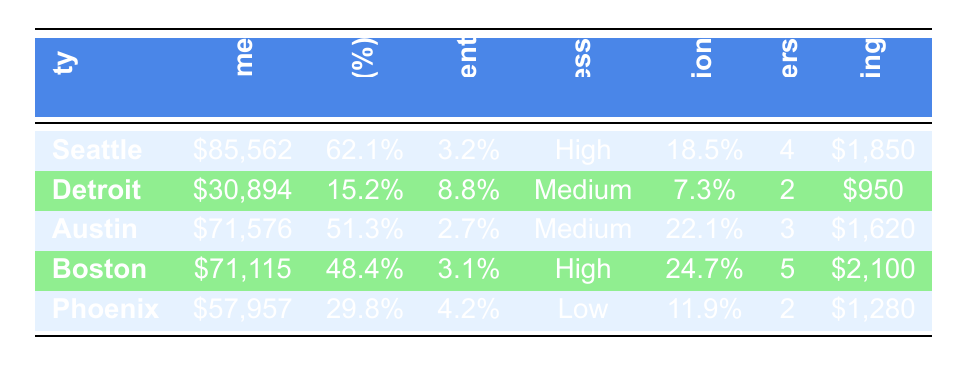What city has the highest median household income? Looking at the "Median Household Income" column, Seattle has the highest value at $85,562.
Answer: Seattle What is the science program participation rate for Boston? The "Science Program Participation Rate" for Boston is listed as 24.7%.
Answer: 24.7% Is the unemployment rate in Austin lower than that in Phoenix? Austin’s unemployment rate is 2.7%, while Phoenix’s is 4.2%, making Austin's rate lower.
Answer: Yes What is the average median household income of the cities listed? The median household incomes are $85,562 (Seattle), $30,894 (Detroit), $71,576 (Austin), $71,115 (Boston), and $57,957 (Phoenix). Summing these gives $317,104, and dividing by 5 cities gives an average of $63,420.8.
Answer: $63,420.8 Are there more local science centers in Seattle than in Detroit? Seattle has 4 local science centers while Detroit has only 2, so Seattle has more.
Answer: Yes What is the difference in science program participation rates between Austin and Detroit? Austin's rate is 22.1%, and Detroit's is 7.3%. To find the difference, subtract 7.3 from 22.1, resulting in 14.8%.
Answer: 14.8% Which city has the lowest education level percentage? By reviewing the "Education Level" column, we see that Detroit has the lowest percentage with 15.2%.
Answer: Detroit What city has both high public transportation access and the highest number of local science centers? Seattle has high public transportation access and has 4 local science centers, which is the highest number listed.
Answer: Seattle What is the STEM school funding per student for Boston and how does it compare to the funding in Detroit? Boston's STEM school funding is $2,100 per student, while Detroit's is $950. The difference is significant, with Boston receiving $1,150 more per student than Detroit.
Answer: $2,100, $1,150 more than Detroit 